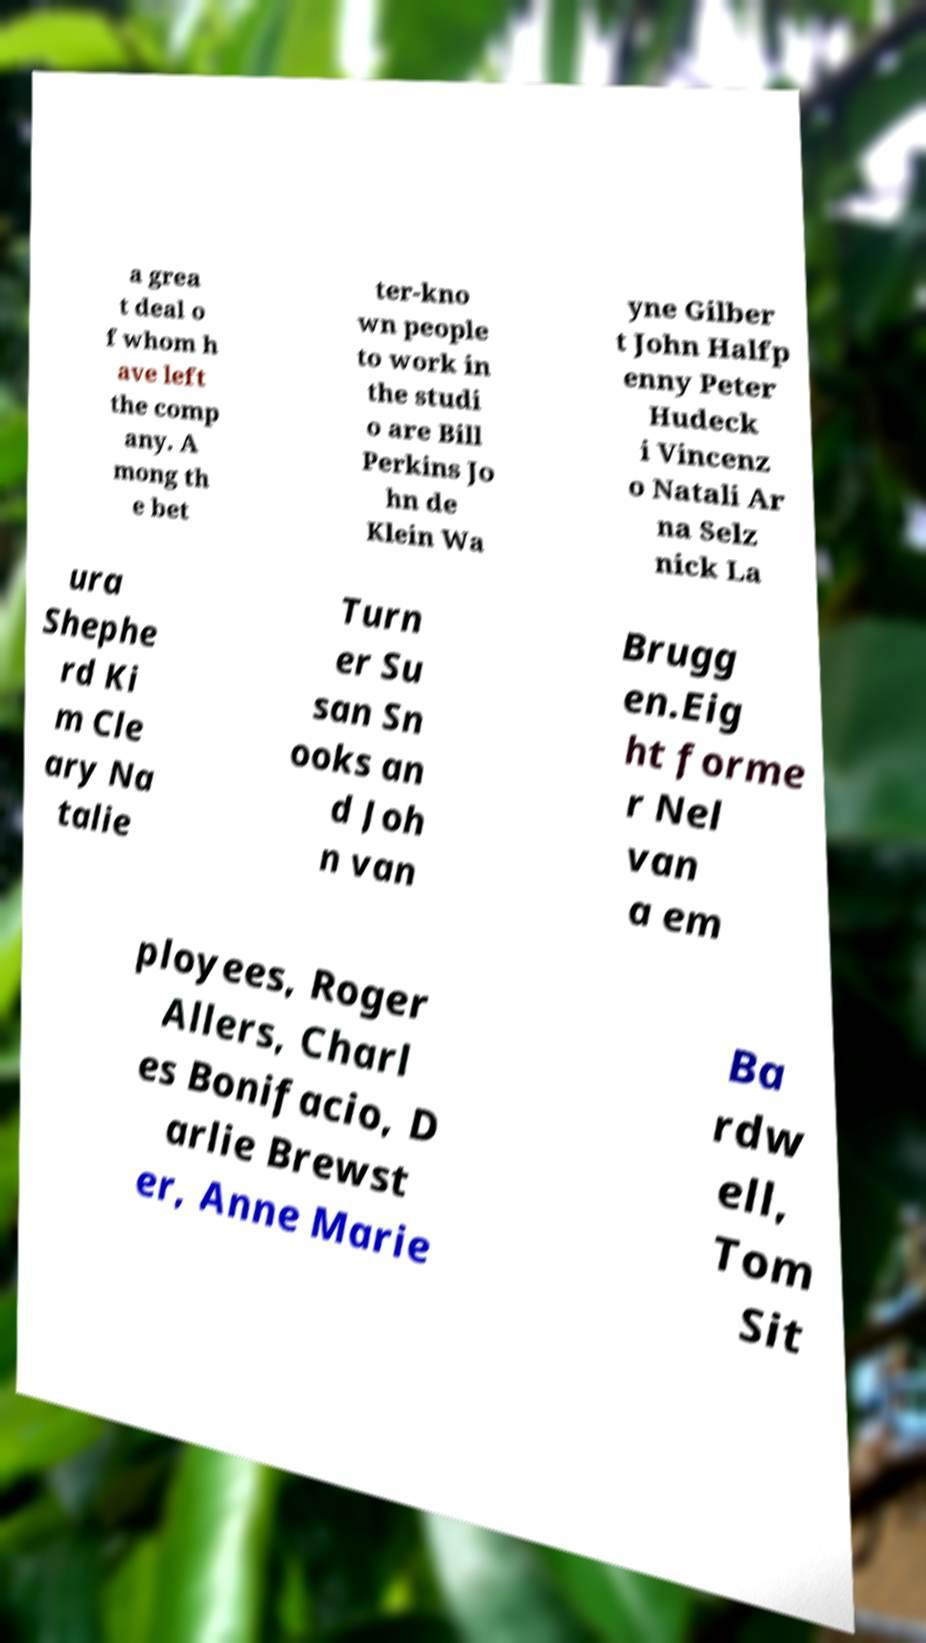Could you extract and type out the text from this image? a grea t deal o f whom h ave left the comp any. A mong th e bet ter-kno wn people to work in the studi o are Bill Perkins Jo hn de Klein Wa yne Gilber t John Halfp enny Peter Hudeck i Vincenz o Natali Ar na Selz nick La ura Shephe rd Ki m Cle ary Na talie Turn er Su san Sn ooks an d Joh n van Brugg en.Eig ht forme r Nel van a em ployees, Roger Allers, Charl es Bonifacio, D arlie Brewst er, Anne Marie Ba rdw ell, Tom Sit 